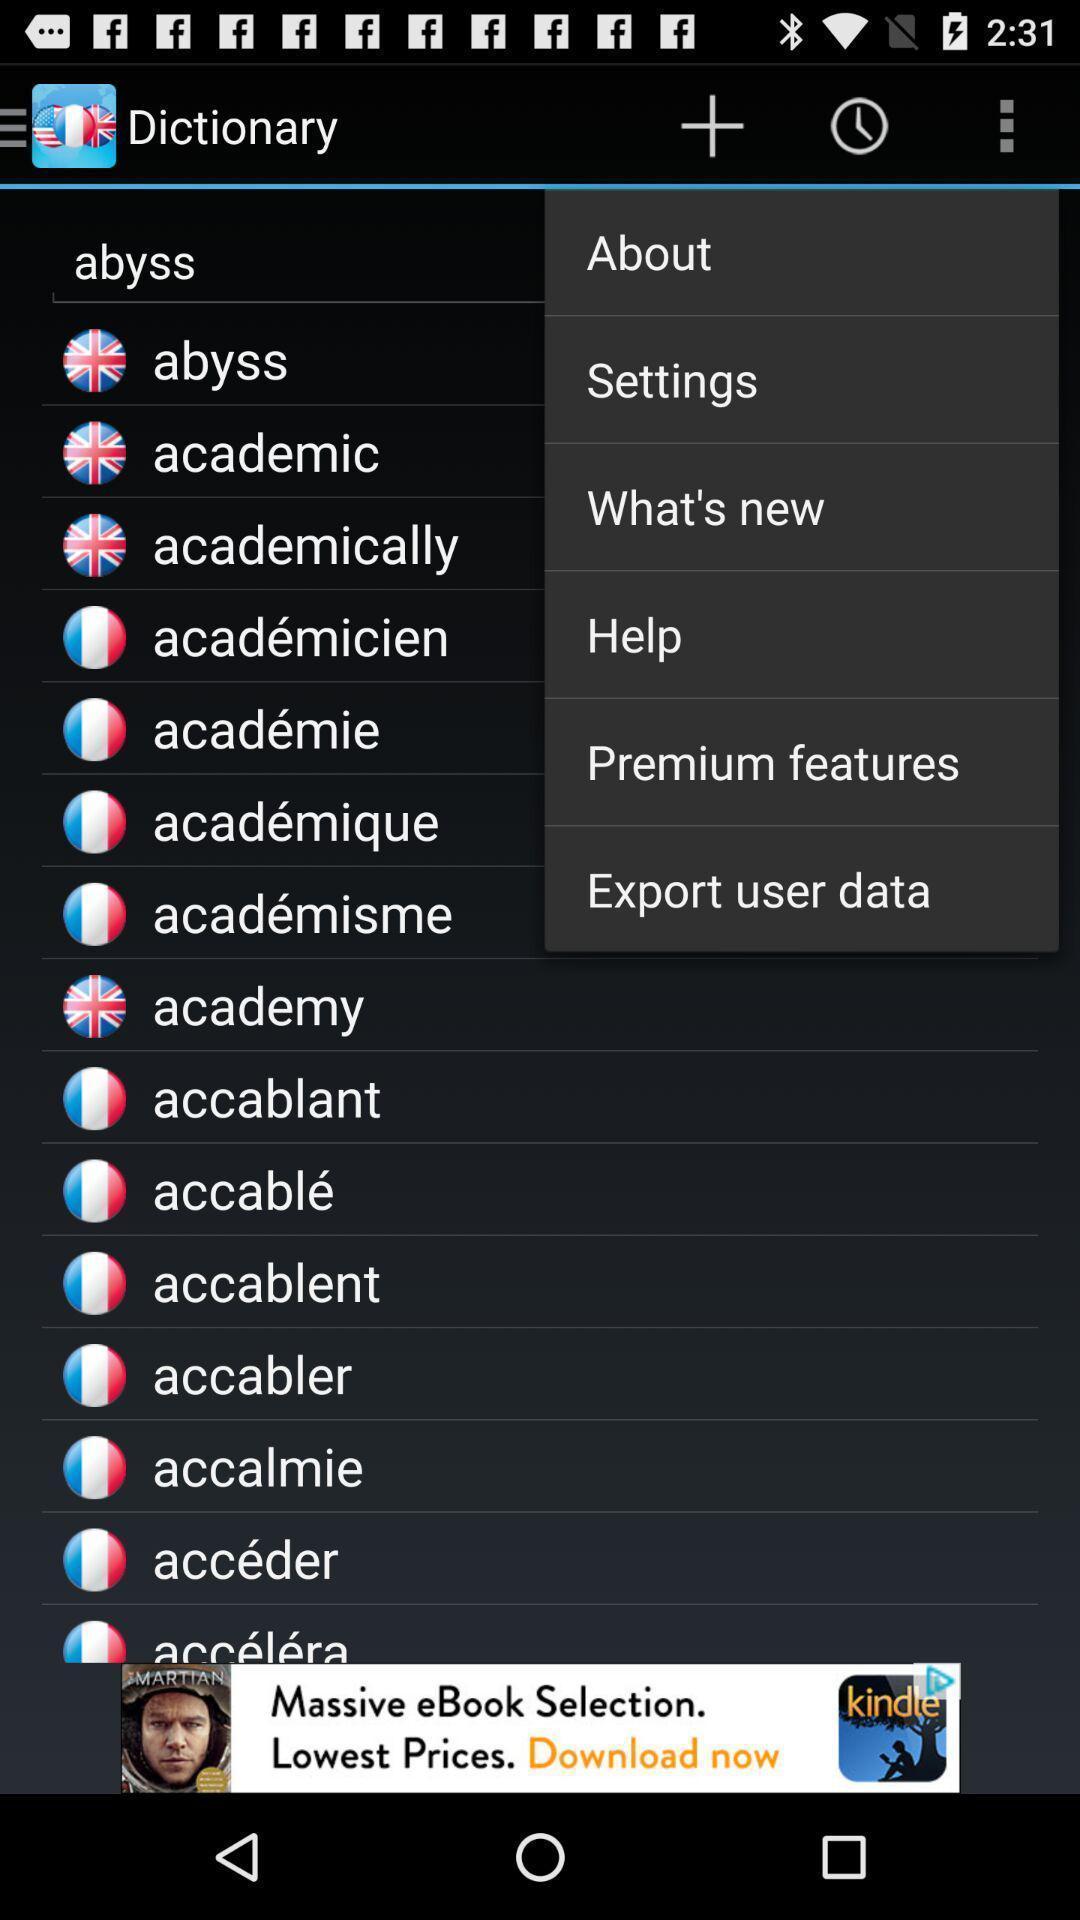Provide a detailed account of this screenshot. Page showing the options. 